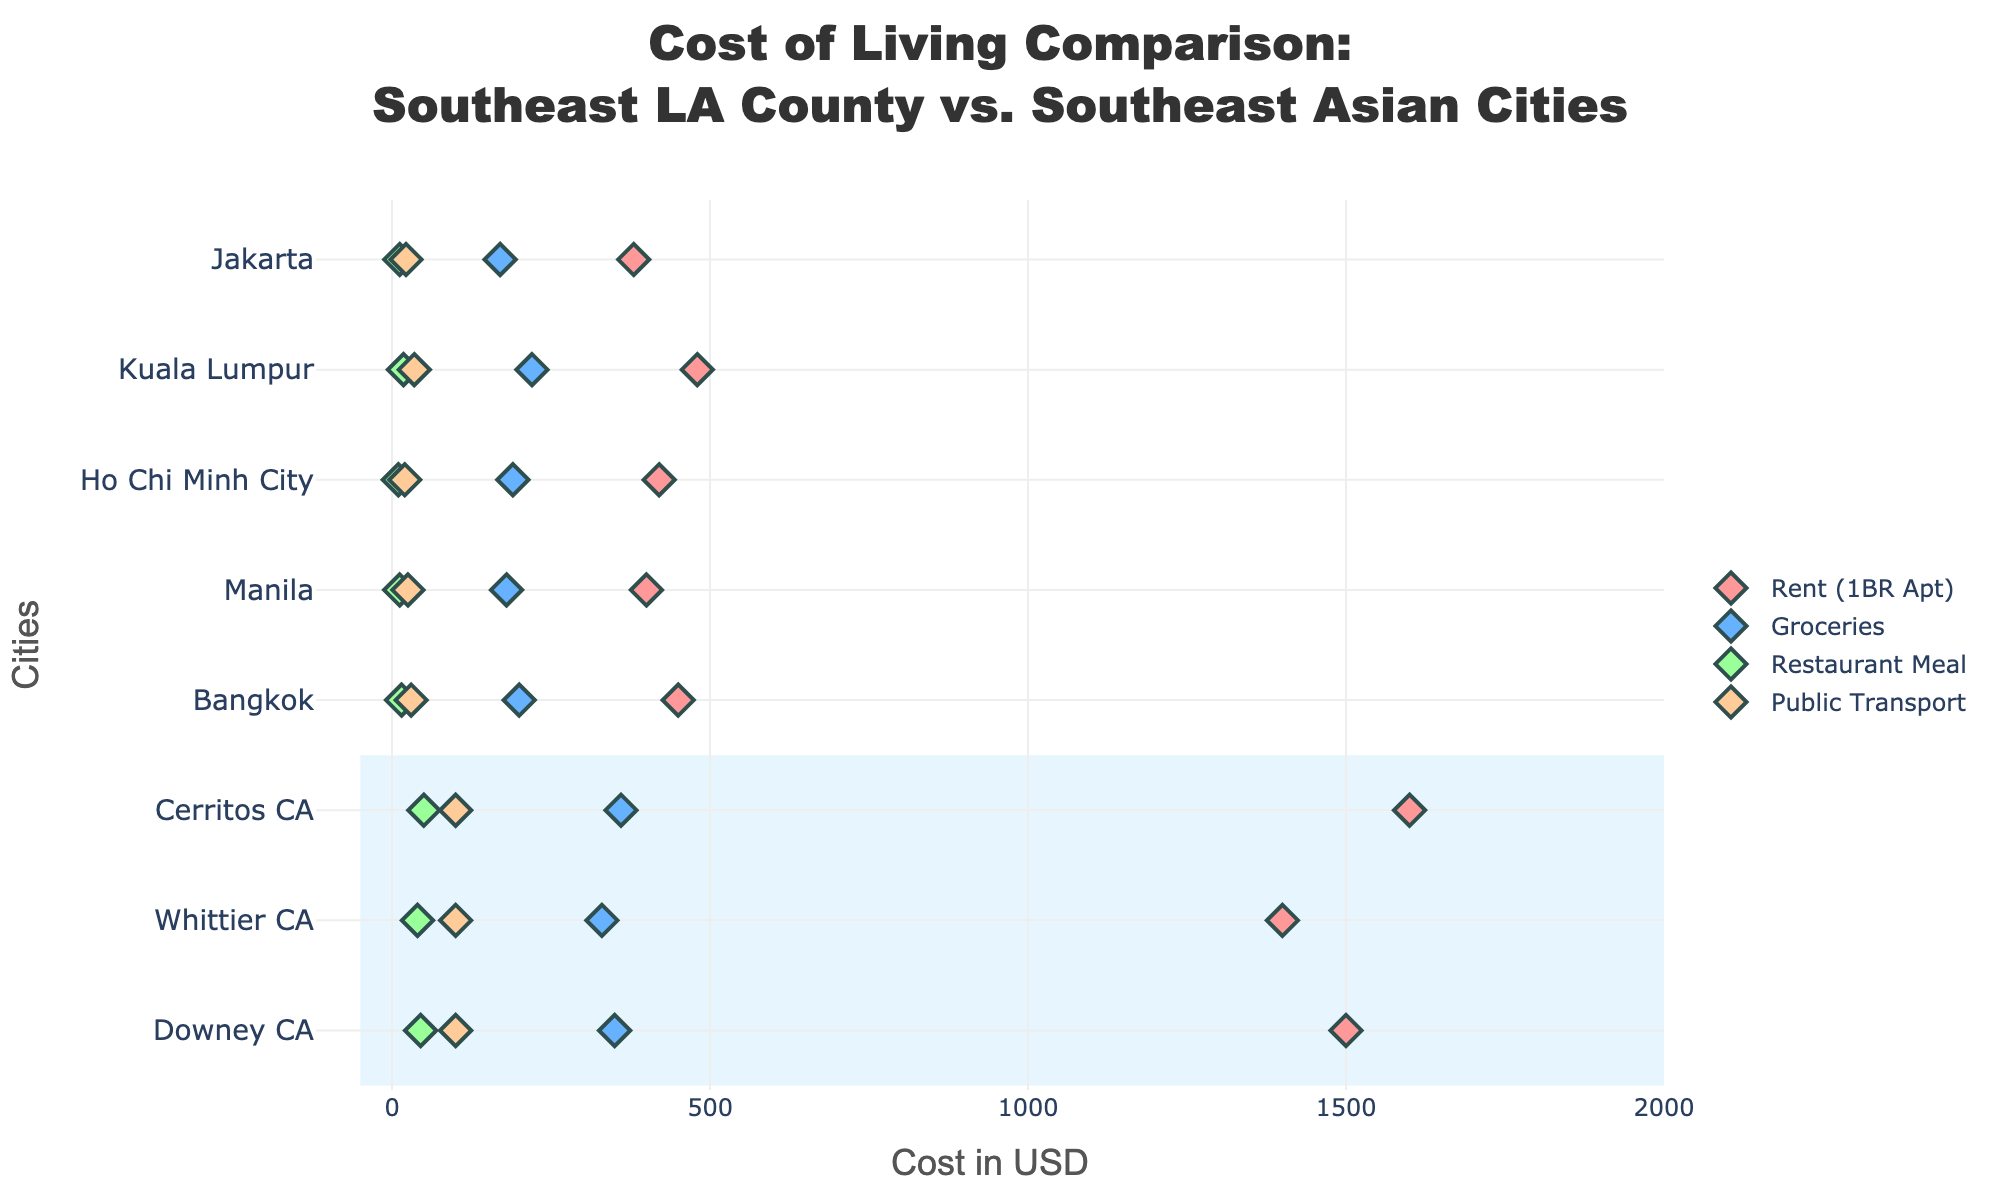What is the title of the plot? The title of the plot is typically located at the top center of the figure. It reads "Cost of Living Comparison: Southeast LA County vs. Southeast Asian Cities".
Answer: Cost of Living Comparison: Southeast LA County vs. Southeast Asian Cities How many cities from Southeast Asia are included in the comparison? To determine this, count the cities listed in the y-axis labels that are identified as being from Southeast Asia. In the plot, these cities are Bangkok, Manila, Ho Chi Minh City, Kuala Lumpur, and Jakarta.
Answer: 5 Which city has the highest cost for Rent (1BR Apt)? Find the city with the highest plot point in the 'Rent (1BR Apt)' category. The dot farthest to the right for Rent (1BR Apt) belongs to Cerritos, CA.
Answer: Cerritos, CA What is the cost difference for Groceries between Downey CA and Bangkok? Locate the points for Groceries for both Downey CA and Bangkok, then subtract the cost of Bangkok from Downey CA (350 - 200).
Answer: 150 Which city has the lowest cost for Public Transport? Find the leftmost dot in the 'Public Transport' category. This dot belongs to Ho Chi Minh City.
Answer: Ho Chi Minh City Among the Southeast LA County cities, which one has the lowest cost for Restaurant Meal? Compare the dots for 'Restaurant Meal' within the Southeast LA County cities (Downey CA, Whittier CA, Cerritos CA). The lowest point is for Whittier CA.
Answer: Whittier CA What is the average cost of a Restaurant Meal in the Southeast Asian cities? Sum the costs of a Restaurant Meal in Southeast Asian cities (Bangkok, Manila, Ho Chi Minh City, Kuala Lumpur, Jakarta) which are 15, 12, 10, 18, and 12 respectively, then divide by the number of cities  (15 + 12 + 10 + 18 + 12) / 5 = 13.4
Answer: 13.4 Is the cost of Groceries in Whittier CA higher than in Jakarta? Compare the y-axis points for Groceries in Whittier CA (330) and Jakarta (170). Yes, 330 is higher than 170.
Answer: Yes In which category does Cerritos CA have the highest cost compared to any Southeast Asian city? Identify the points for Cerritos CA in all categories and compare them to the Southeast Asian cities. The largest difference is found in Rent (1BR Apt) where 1600 (Cerritos CA) is far higher than the maximum in Southeast Asia (480 in Kuala Lumpur).
Answer: Rent (1BR Apt) Which city has the lowest combined cost of Restaurant Meal and Public Transport? Sum the costs of Restaurant Meal and Public Transport for each city and compare the sums. For Ho Chi Minh City, the combined cost is the lowest at 30 (10 + 20).
Answer: Ho Chi Minh City 